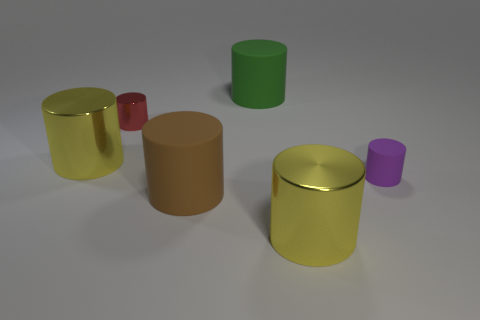Subtract all green rubber cylinders. How many cylinders are left? 5 Subtract all brown cylinders. How many cylinders are left? 5 Subtract all gray cylinders. Subtract all cyan balls. How many cylinders are left? 6 Add 2 cylinders. How many objects exist? 8 Add 3 tiny metal cylinders. How many tiny metal cylinders are left? 4 Add 1 small yellow cylinders. How many small yellow cylinders exist? 1 Subtract 1 purple cylinders. How many objects are left? 5 Subtract all small purple cylinders. Subtract all green rubber cylinders. How many objects are left? 4 